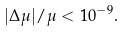<formula> <loc_0><loc_0><loc_500><loc_500>| \Delta \mu | / \mu < 1 0 ^ { - 9 } .</formula> 